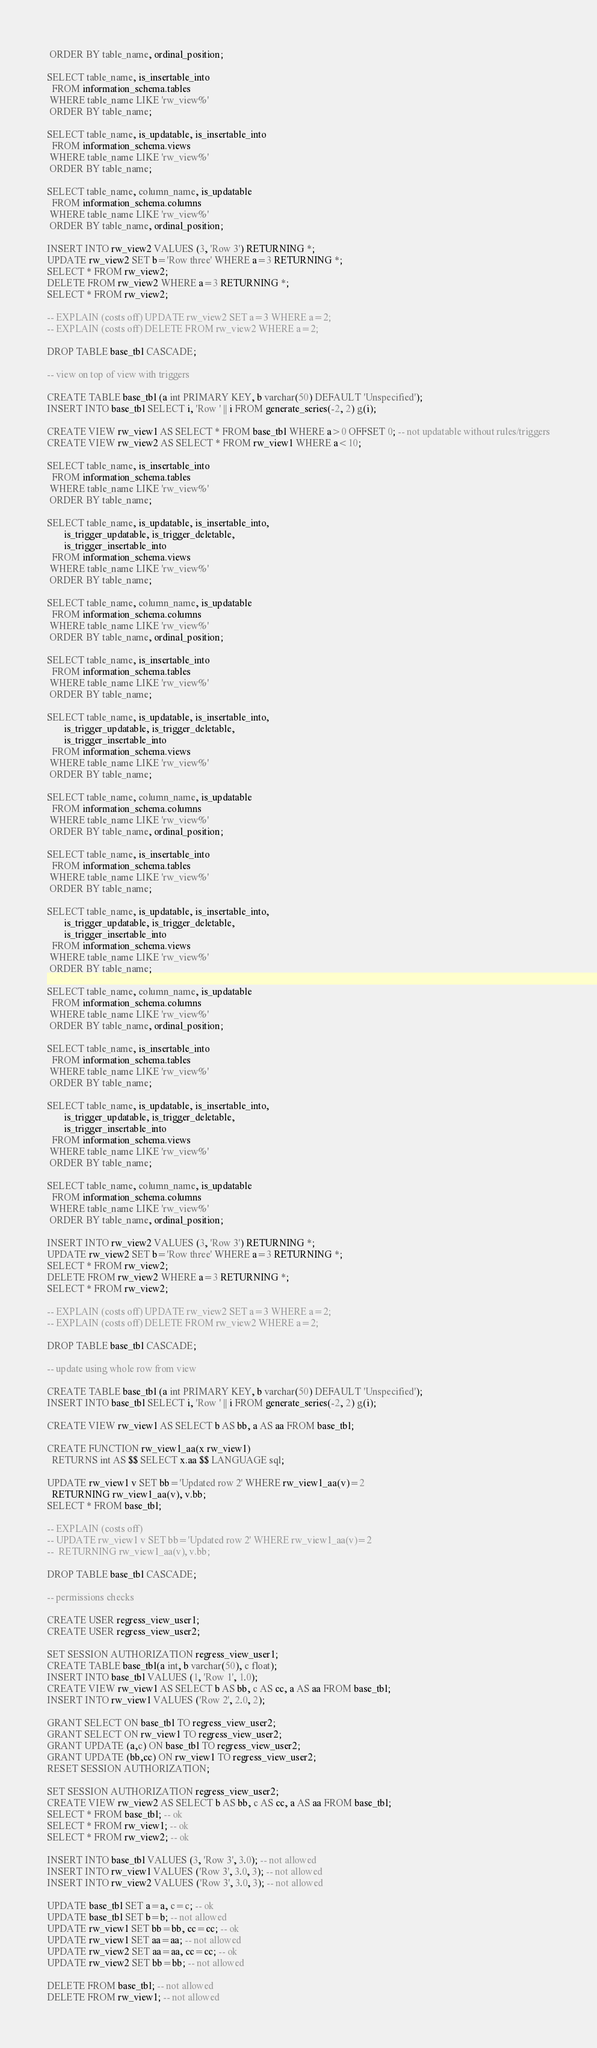Convert code to text. <code><loc_0><loc_0><loc_500><loc_500><_SQL_> ORDER BY table_name, ordinal_position;

SELECT table_name, is_insertable_into
  FROM information_schema.tables
 WHERE table_name LIKE 'rw_view%'
 ORDER BY table_name;

SELECT table_name, is_updatable, is_insertable_into
  FROM information_schema.views
 WHERE table_name LIKE 'rw_view%'
 ORDER BY table_name;

SELECT table_name, column_name, is_updatable
  FROM information_schema.columns
 WHERE table_name LIKE 'rw_view%'
 ORDER BY table_name, ordinal_position;

INSERT INTO rw_view2 VALUES (3, 'Row 3') RETURNING *;
UPDATE rw_view2 SET b='Row three' WHERE a=3 RETURNING *;
SELECT * FROM rw_view2;
DELETE FROM rw_view2 WHERE a=3 RETURNING *;
SELECT * FROM rw_view2;

-- EXPLAIN (costs off) UPDATE rw_view2 SET a=3 WHERE a=2;
-- EXPLAIN (costs off) DELETE FROM rw_view2 WHERE a=2;

DROP TABLE base_tbl CASCADE;

-- view on top of view with triggers

CREATE TABLE base_tbl (a int PRIMARY KEY, b varchar(50) DEFAULT 'Unspecified');
INSERT INTO base_tbl SELECT i, 'Row ' || i FROM generate_series(-2, 2) g(i);

CREATE VIEW rw_view1 AS SELECT * FROM base_tbl WHERE a>0 OFFSET 0; -- not updatable without rules/triggers
CREATE VIEW rw_view2 AS SELECT * FROM rw_view1 WHERE a<10;

SELECT table_name, is_insertable_into
  FROM information_schema.tables
 WHERE table_name LIKE 'rw_view%'
 ORDER BY table_name;

SELECT table_name, is_updatable, is_insertable_into,
       is_trigger_updatable, is_trigger_deletable,
       is_trigger_insertable_into
  FROM information_schema.views
 WHERE table_name LIKE 'rw_view%'
 ORDER BY table_name;

SELECT table_name, column_name, is_updatable
  FROM information_schema.columns
 WHERE table_name LIKE 'rw_view%'
 ORDER BY table_name, ordinal_position;

SELECT table_name, is_insertable_into
  FROM information_schema.tables
 WHERE table_name LIKE 'rw_view%'
 ORDER BY table_name;

SELECT table_name, is_updatable, is_insertable_into,
       is_trigger_updatable, is_trigger_deletable,
       is_trigger_insertable_into
  FROM information_schema.views
 WHERE table_name LIKE 'rw_view%'
 ORDER BY table_name;

SELECT table_name, column_name, is_updatable
  FROM information_schema.columns
 WHERE table_name LIKE 'rw_view%'
 ORDER BY table_name, ordinal_position;

SELECT table_name, is_insertable_into
  FROM information_schema.tables
 WHERE table_name LIKE 'rw_view%'
 ORDER BY table_name;

SELECT table_name, is_updatable, is_insertable_into,
       is_trigger_updatable, is_trigger_deletable,
       is_trigger_insertable_into
  FROM information_schema.views
 WHERE table_name LIKE 'rw_view%'
 ORDER BY table_name;

SELECT table_name, column_name, is_updatable
  FROM information_schema.columns
 WHERE table_name LIKE 'rw_view%'
 ORDER BY table_name, ordinal_position;

SELECT table_name, is_insertable_into
  FROM information_schema.tables
 WHERE table_name LIKE 'rw_view%'
 ORDER BY table_name;

SELECT table_name, is_updatable, is_insertable_into,
       is_trigger_updatable, is_trigger_deletable,
       is_trigger_insertable_into
  FROM information_schema.views
 WHERE table_name LIKE 'rw_view%'
 ORDER BY table_name;

SELECT table_name, column_name, is_updatable
  FROM information_schema.columns
 WHERE table_name LIKE 'rw_view%'
 ORDER BY table_name, ordinal_position;

INSERT INTO rw_view2 VALUES (3, 'Row 3') RETURNING *;
UPDATE rw_view2 SET b='Row three' WHERE a=3 RETURNING *;
SELECT * FROM rw_view2;
DELETE FROM rw_view2 WHERE a=3 RETURNING *;
SELECT * FROM rw_view2;

-- EXPLAIN (costs off) UPDATE rw_view2 SET a=3 WHERE a=2;
-- EXPLAIN (costs off) DELETE FROM rw_view2 WHERE a=2;

DROP TABLE base_tbl CASCADE;

-- update using whole row from view

CREATE TABLE base_tbl (a int PRIMARY KEY, b varchar(50) DEFAULT 'Unspecified');
INSERT INTO base_tbl SELECT i, 'Row ' || i FROM generate_series(-2, 2) g(i);

CREATE VIEW rw_view1 AS SELECT b AS bb, a AS aa FROM base_tbl;

CREATE FUNCTION rw_view1_aa(x rw_view1)
  RETURNS int AS $$ SELECT x.aa $$ LANGUAGE sql;

UPDATE rw_view1 v SET bb='Updated row 2' WHERE rw_view1_aa(v)=2
  RETURNING rw_view1_aa(v), v.bb;
SELECT * FROM base_tbl;

-- EXPLAIN (costs off)
-- UPDATE rw_view1 v SET bb='Updated row 2' WHERE rw_view1_aa(v)=2
--  RETURNING rw_view1_aa(v), v.bb;

DROP TABLE base_tbl CASCADE;

-- permissions checks

CREATE USER regress_view_user1;
CREATE USER regress_view_user2;

SET SESSION AUTHORIZATION regress_view_user1;
CREATE TABLE base_tbl(a int, b varchar(50), c float);
INSERT INTO base_tbl VALUES (1, 'Row 1', 1.0);
CREATE VIEW rw_view1 AS SELECT b AS bb, c AS cc, a AS aa FROM base_tbl;
INSERT INTO rw_view1 VALUES ('Row 2', 2.0, 2);

GRANT SELECT ON base_tbl TO regress_view_user2;
GRANT SELECT ON rw_view1 TO regress_view_user2;
GRANT UPDATE (a,c) ON base_tbl TO regress_view_user2;
GRANT UPDATE (bb,cc) ON rw_view1 TO regress_view_user2;
RESET SESSION AUTHORIZATION;

SET SESSION AUTHORIZATION regress_view_user2;
CREATE VIEW rw_view2 AS SELECT b AS bb, c AS cc, a AS aa FROM base_tbl;
SELECT * FROM base_tbl; -- ok
SELECT * FROM rw_view1; -- ok
SELECT * FROM rw_view2; -- ok

INSERT INTO base_tbl VALUES (3, 'Row 3', 3.0); -- not allowed
INSERT INTO rw_view1 VALUES ('Row 3', 3.0, 3); -- not allowed
INSERT INTO rw_view2 VALUES ('Row 3', 3.0, 3); -- not allowed

UPDATE base_tbl SET a=a, c=c; -- ok
UPDATE base_tbl SET b=b; -- not allowed
UPDATE rw_view1 SET bb=bb, cc=cc; -- ok
UPDATE rw_view1 SET aa=aa; -- not allowed
UPDATE rw_view2 SET aa=aa, cc=cc; -- ok
UPDATE rw_view2 SET bb=bb; -- not allowed

DELETE FROM base_tbl; -- not allowed
DELETE FROM rw_view1; -- not allowed</code> 